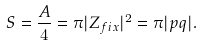Convert formula to latex. <formula><loc_0><loc_0><loc_500><loc_500>S = \frac { A } { 4 } = \pi | Z _ { f i x } | ^ { 2 } = \pi | p q | .</formula> 